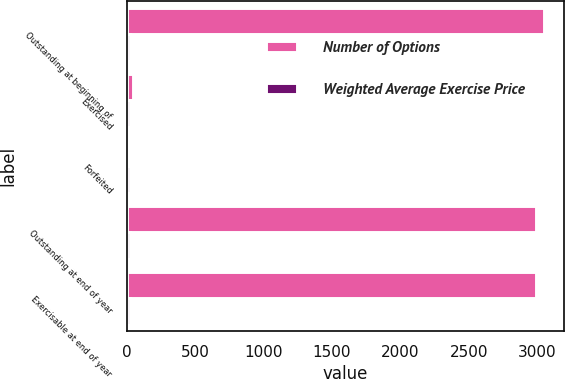<chart> <loc_0><loc_0><loc_500><loc_500><stacked_bar_chart><ecel><fcel>Outstanding at beginning of<fcel>Exercised<fcel>Forfeited<fcel>Outstanding at end of year<fcel>Exercisable at end of year<nl><fcel>Number of Options<fcel>3045<fcel>44<fcel>10<fcel>2991<fcel>2991<nl><fcel>Weighted Average Exercise Price<fcel>28.39<fcel>22.52<fcel>27.82<fcel>28.48<fcel>28.48<nl></chart> 